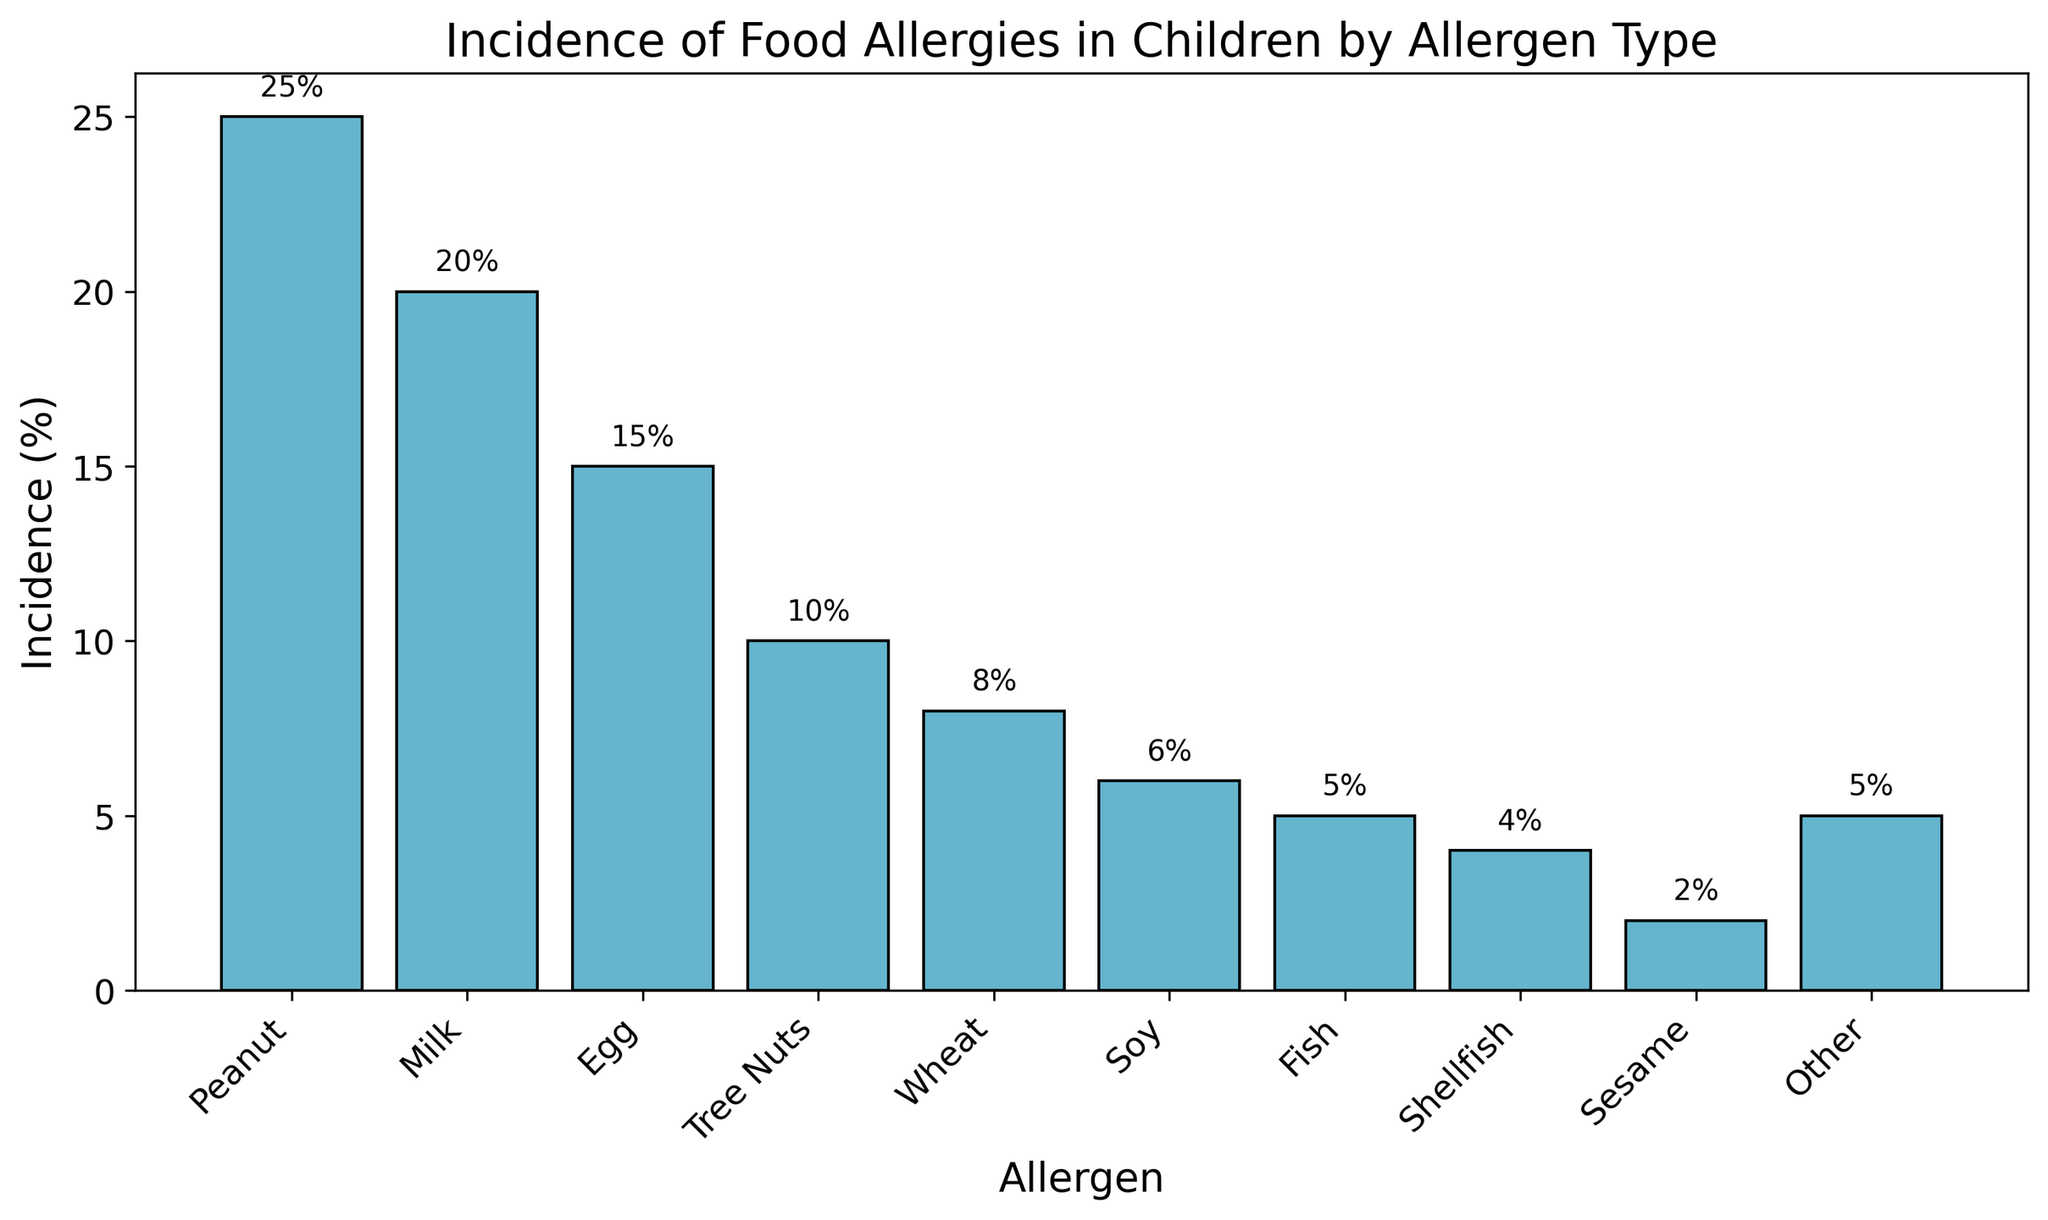Which allergen has the highest incidence of food allergies in children? By examining the heights of the bars in the bar chart, the tallest bar corresponds to the allergen with the highest incidence. The peanut allergen bar is the tallest.
Answer: Peanut Which two allergens have the combined lowest incidence of food allergies, and what is that combined incidence percentage? The lowest bars in the bar chart correspond to Sesame and Shellfish, each at 2% and 4%, respectively. The combined incidence is 2% + 4% = 6%.
Answer: Sesame and Shellfish, 6% How much higher is the incidence of peanut allergies compared to milk allergies? The height of the peanut bar is at 25%, and the height of the milk bar is at 20%. The difference is 25% - 20% = 5%.
Answer: 5% Out of all the allergens listed, which has the median incidence percentage? Arranging the incidence percentages in ascending order: 2%, 4%, 5%, 5%, 6%, 8%, 10%, 15%, 20%, 25%. The median is in the middle, which is the 5th and 6th values averaged: (8% + 6%) / 2 = 7%.
Answer: Soy and Wheat, average 7% What is the sum of the incidences of egg, tree nuts, and wheat allergies? The incidence percentages are 15% for egg, 10% for tree nuts, and 8% for wheat. Summing them up gives 15% + 10% + 8% = 33%.
Answer: 33% Which allergens have an incidence rate of less than 10%? By examining the bars below the 10% mark, the allergens are Wheat (8%), Soy (6%), Fish (5%), Shellfish (4%), Sesame (2%), and Other (5%).
Answer: Wheat, Soy, Fish, Shellfish, Sesame, Other If a pediatric clinic saw 200 children, approximately how many would have a peanut allergy? The incidence of peanut allergies is 25%. Therefore, 25% of 200 children is calculated as 0.25 * 200 = 50 children.
Answer: 50 children Is the incidence of egg allergies closer to the incidence of milk allergies or tree nuts allergies? The incidence of egg allergies is 15%. For milk, it's 20% (difference of 5%) and for tree nuts, it's 10% (difference of 5%). Both milk and tree nuts are equally close.
Answer: Both equally close, 5% difference Are there more types of allergens with an incidence greater than, equal to, or less than 10%? Count the incidences for these ranges: 
Greater than 10%: Peanut (25%), Milk (20%), Egg (15%) 
Equal to 10%: Tree Nuts (10%) 
Less than 10%: Wheat (8%), Soy (6%), Fish (5%), Shellfish (4%), Sesame (2%), Other (5%) 
Count: Greater (3), Equal (1), Less (6).
Answer: Less Which allergens have an incidence rate equal to the sum of incidences for soy and sesame allergies? The sum of soy (6%) and sesame (2%) equals 8%. The allergen with an incidence of 8% is Wheat.
Answer: Wheat 